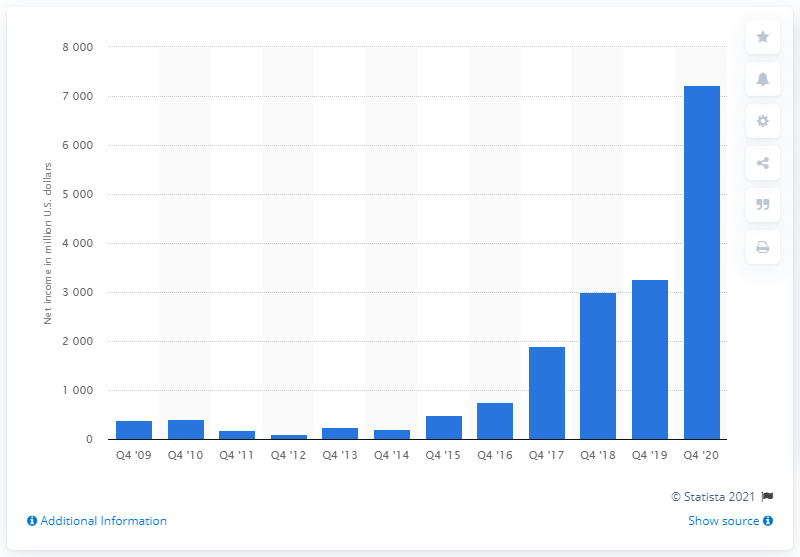Draw attention to some important aspects in this diagram. Amazon's net income in 2020 was 72,220. 